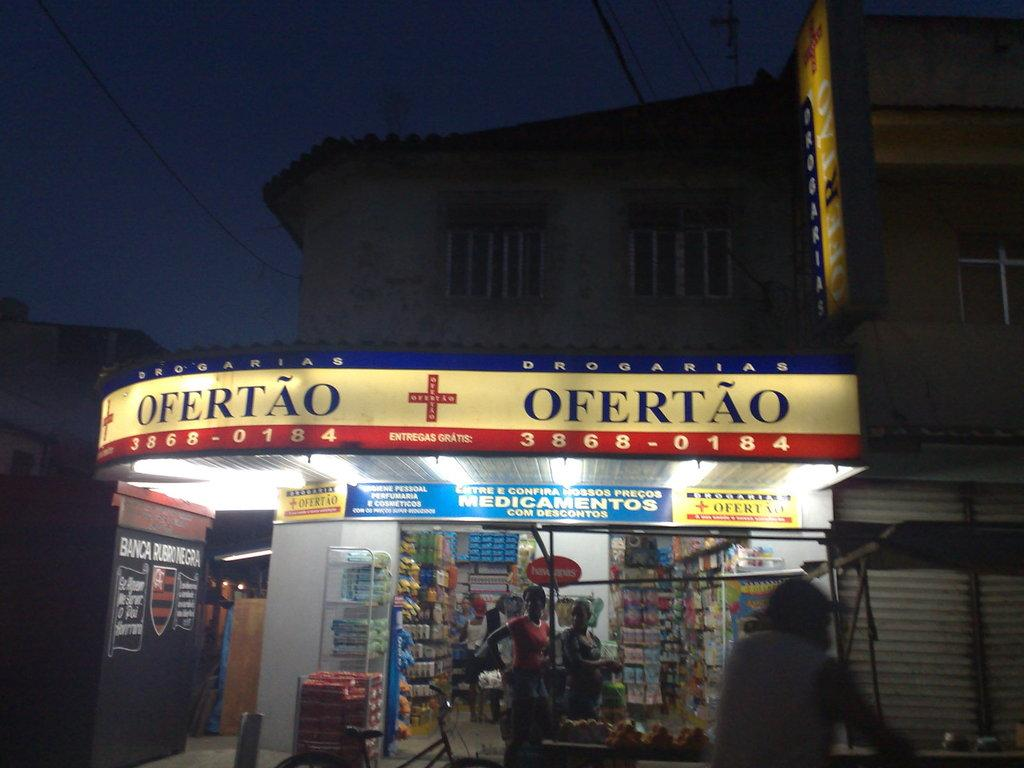<image>
Provide a brief description of the given image. A drugstore called Ofertao is open and serving customers at night. 